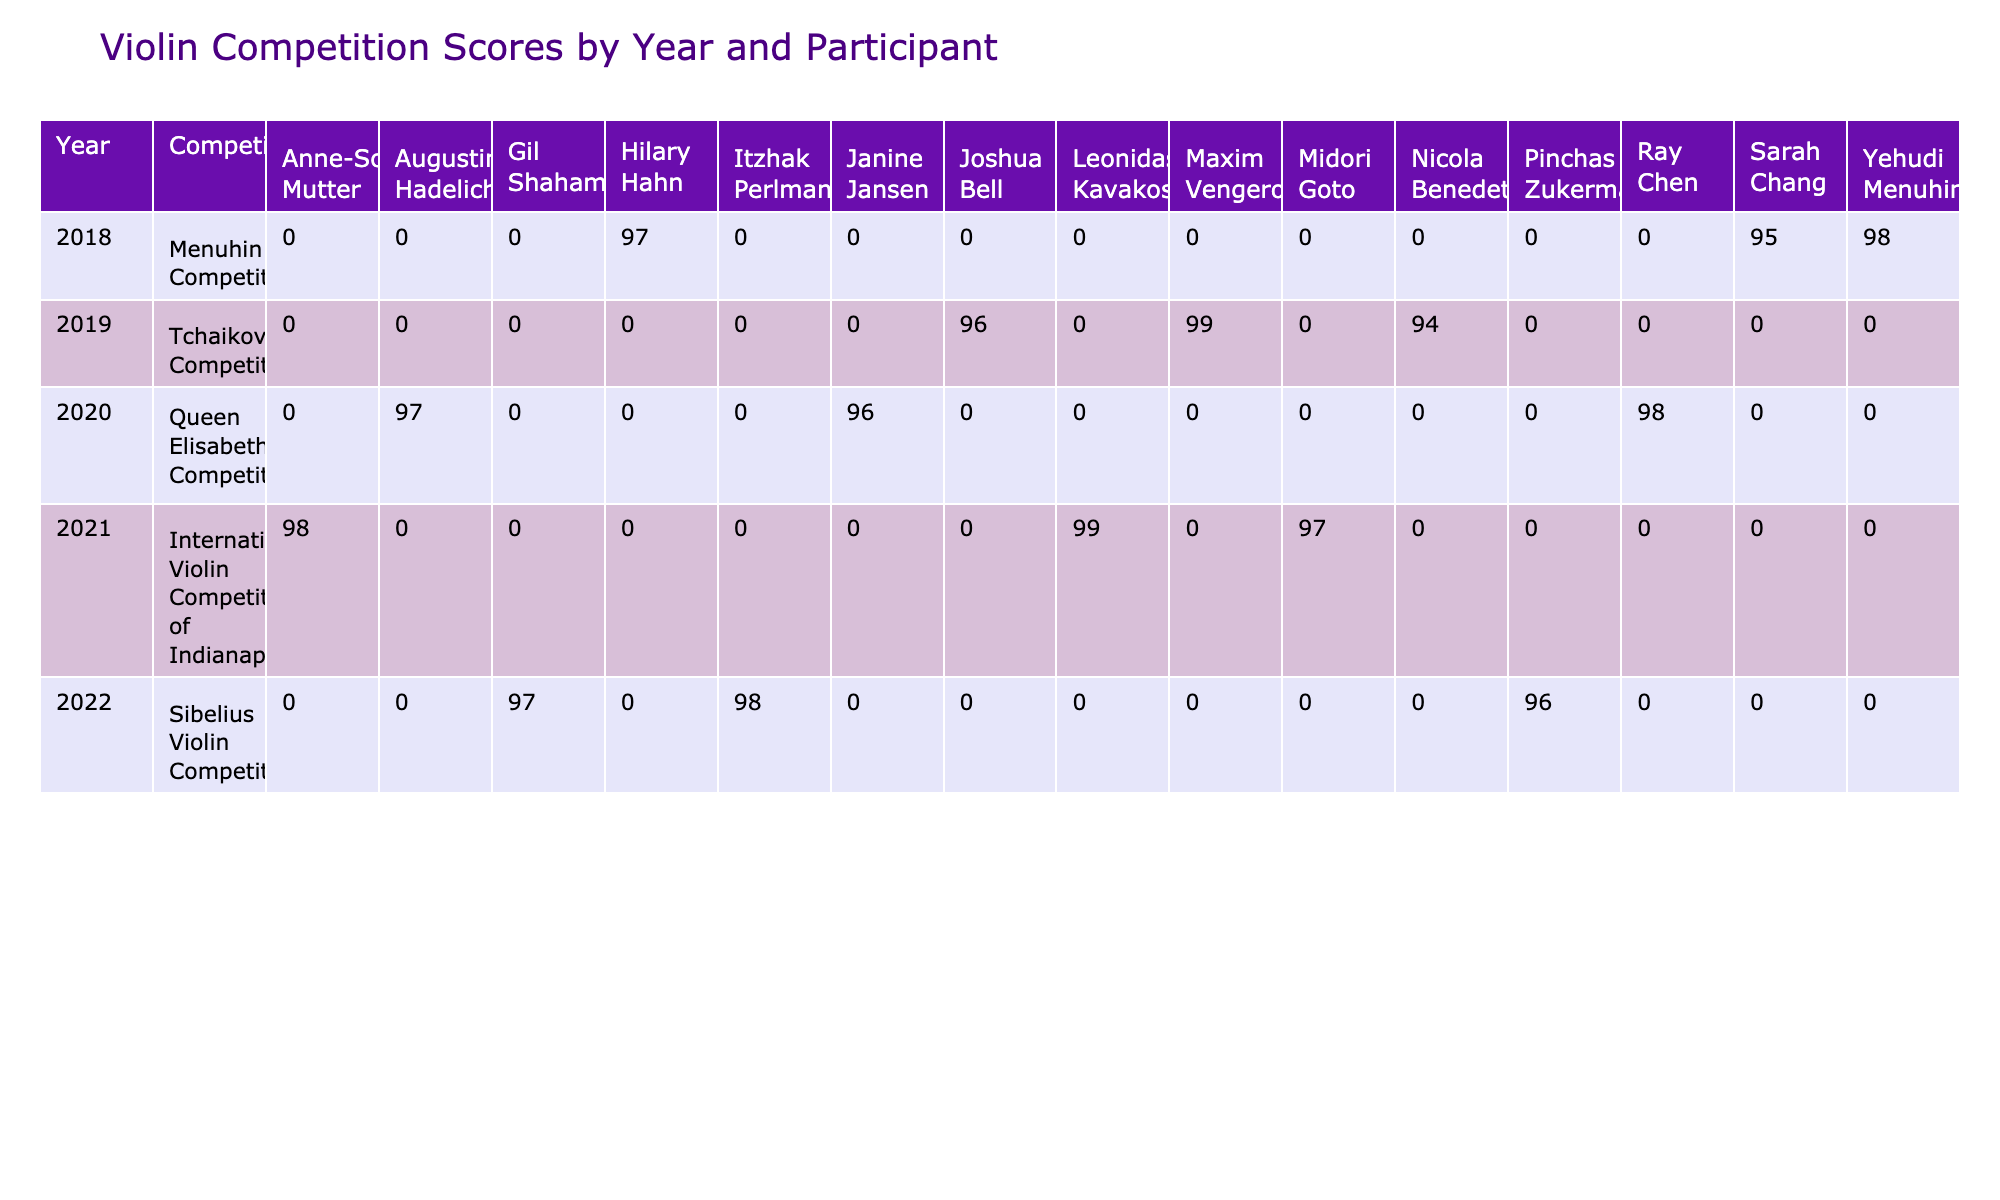What was the highest score in the Menuhin Competition? The highest score listed in the Menuhin Competition is from Yehudi Menuhin, who achieved a score of 98 in 2018.
Answer: 98 Which participant had the lowest score in the Tchaikovsky Competition? In the Tchaikovsky Competition, Nicola Benedetti had the lowest score of 94 in 2019.
Answer: 94 What is the average score of participants in the Queen Elisabeth Competition? The scores for the Queen Elisabeth Competition in 2020 are 98, 97, and 96. Summing them gives 98 + 97 + 96 = 291. There are 3 participants, so the average score is 291 / 3 = 97.
Answer: 97 Did any participant achieve a score of 99? Yes, Maxim Vengerov achieved a score of 99 in the Tchaikovsky Competition in 2019, and Leonidas Kavakos also scored 99 in the International Violin Competition of Indianapolis in 2021.
Answer: Yes What was the difference between the highest and lowest scores in the Sibelius Violin Competition? The highest score in the Sibelius Violin Competition was 98 (achieved by Itzhak Perlman in 2022), and the lowest was 96 (achieved by Pinchas Zukerman in 2022). The difference is 98 - 96 = 2.
Answer: 2 Which country had the most participants in the competitions listed? By reviewing the participants, the USA had the most entries with a total of four participants: Sarah Chang, Hilary Hahn, Itzhak Perlman, and Gil Shaham across different competitions.
Answer: USA What was the total score of Anne-Sophie Mutter in the International Violin Competition of Indianapolis? Anne-Sophie Mutter scored 98 in the International Violin Competition of Indianapolis in 2021, which is the only score listed for her. Thus, her total score is simply 98.
Answer: 98 How many participants scored over 97 in 2021? In 2021, two participants had scores over 97: Leonidas Kavakos with 99 and Anne-Sophie Mutter with 98. Midori Goto scored 97, which is not above 97. Therefore, there were 2 participants scoring over 97.
Answer: 2 